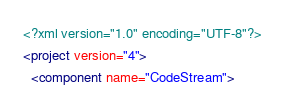<code> <loc_0><loc_0><loc_500><loc_500><_XML_><?xml version="1.0" encoding="UTF-8"?>
<project version="4">
  <component name="CodeStream"></code> 